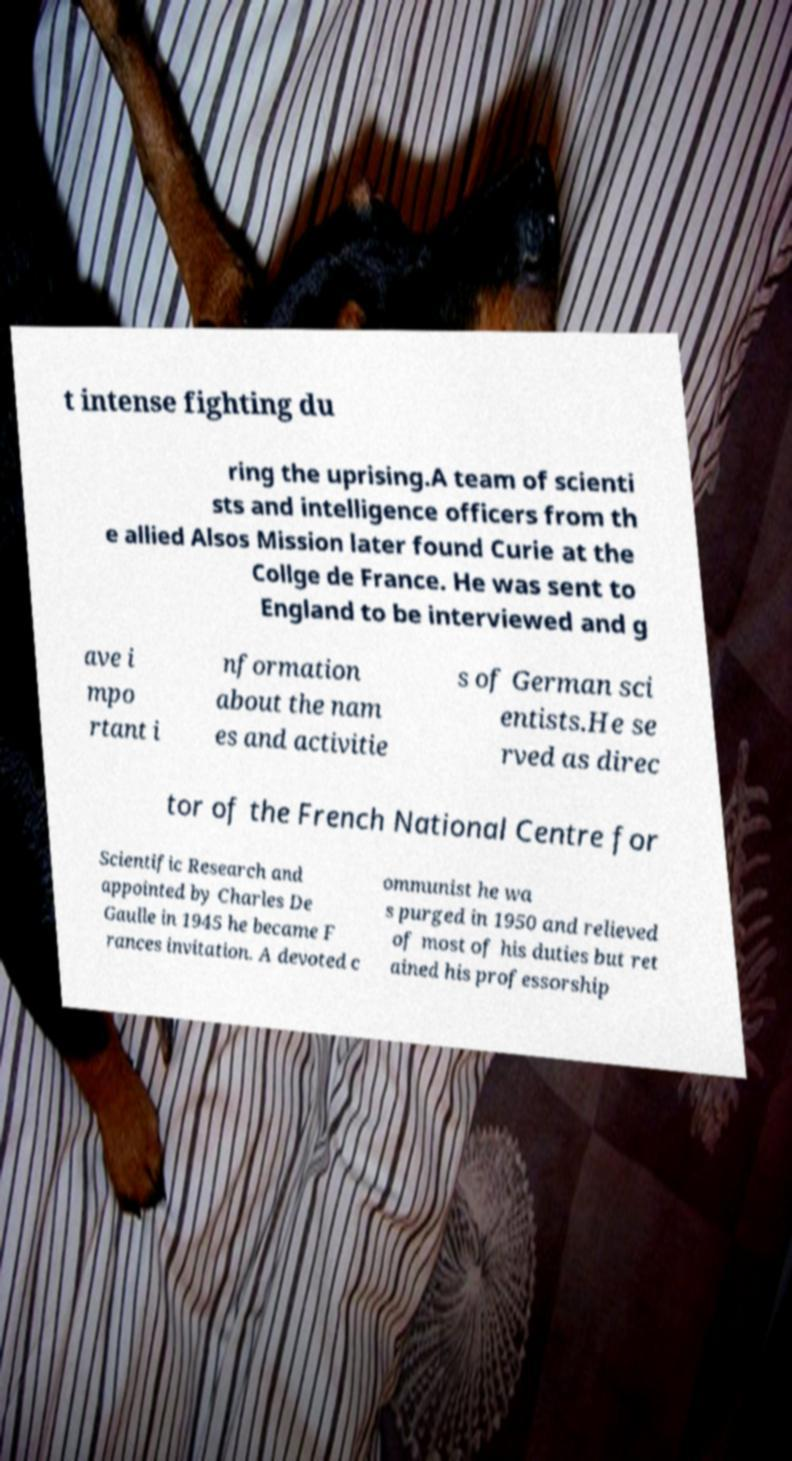Can you read and provide the text displayed in the image?This photo seems to have some interesting text. Can you extract and type it out for me? t intense fighting du ring the uprising.A team of scienti sts and intelligence officers from th e allied Alsos Mission later found Curie at the Collge de France. He was sent to England to be interviewed and g ave i mpo rtant i nformation about the nam es and activitie s of German sci entists.He se rved as direc tor of the French National Centre for Scientific Research and appointed by Charles De Gaulle in 1945 he became F rances invitation. A devoted c ommunist he wa s purged in 1950 and relieved of most of his duties but ret ained his professorship 